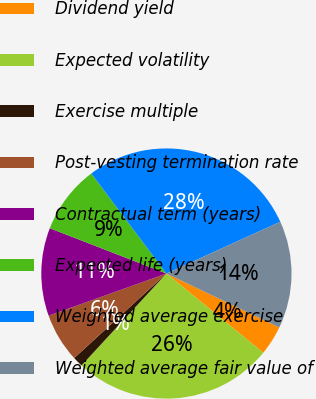<chart> <loc_0><loc_0><loc_500><loc_500><pie_chart><fcel>Dividend yield<fcel>Expected volatility<fcel>Exercise multiple<fcel>Post-vesting termination rate<fcel>Contractual term (years)<fcel>Expected life (years)<fcel>Weighted average exercise<fcel>Weighted average fair value of<nl><fcel>3.83%<fcel>25.95%<fcel>1.32%<fcel>6.34%<fcel>11.37%<fcel>8.85%<fcel>28.46%<fcel>13.88%<nl></chart> 